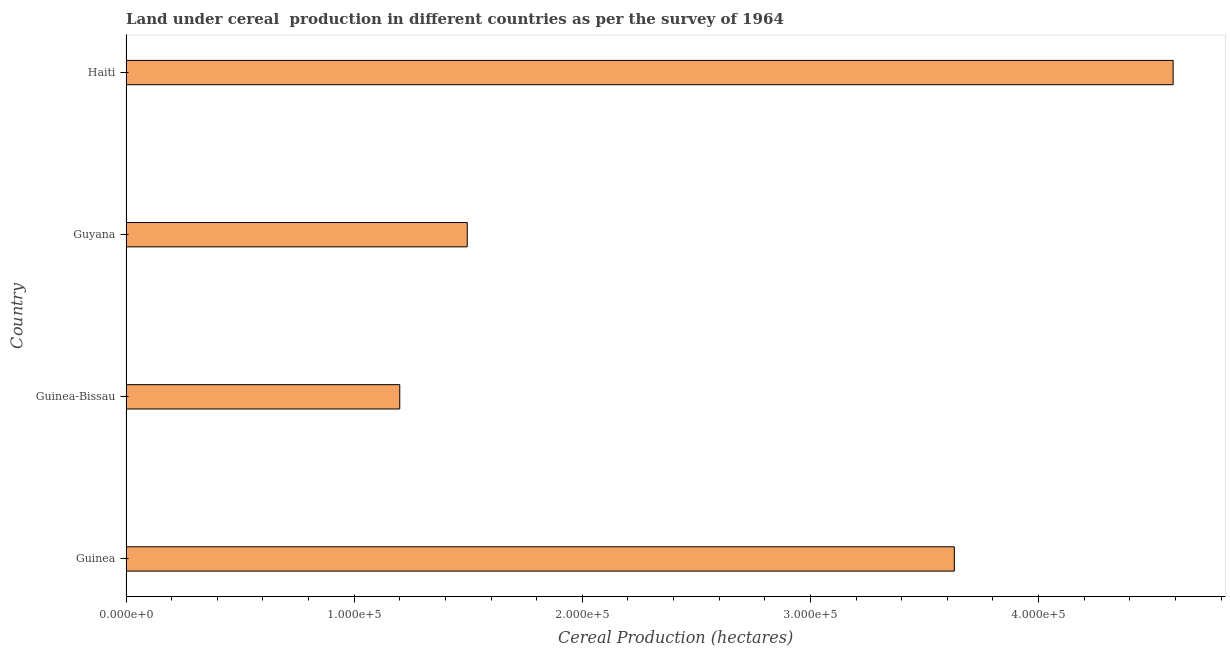What is the title of the graph?
Your response must be concise. Land under cereal  production in different countries as per the survey of 1964. What is the label or title of the X-axis?
Keep it short and to the point. Cereal Production (hectares). What is the land under cereal production in Guinea?
Your answer should be compact. 3.63e+05. Across all countries, what is the maximum land under cereal production?
Ensure brevity in your answer.  4.59e+05. Across all countries, what is the minimum land under cereal production?
Offer a very short reply. 1.20e+05. In which country was the land under cereal production maximum?
Provide a short and direct response. Haiti. In which country was the land under cereal production minimum?
Your answer should be very brief. Guinea-Bissau. What is the sum of the land under cereal production?
Make the answer very short. 1.09e+06. What is the difference between the land under cereal production in Guinea and Guyana?
Your response must be concise. 2.14e+05. What is the average land under cereal production per country?
Provide a short and direct response. 2.73e+05. What is the median land under cereal production?
Provide a succinct answer. 2.56e+05. What is the ratio of the land under cereal production in Guinea to that in Guyana?
Give a very brief answer. 2.43. Is the difference between the land under cereal production in Guinea and Haiti greater than the difference between any two countries?
Keep it short and to the point. No. What is the difference between the highest and the second highest land under cereal production?
Keep it short and to the point. 9.59e+04. Is the sum of the land under cereal production in Guinea and Guyana greater than the maximum land under cereal production across all countries?
Your answer should be compact. Yes. What is the difference between the highest and the lowest land under cereal production?
Your answer should be compact. 3.39e+05. How many countries are there in the graph?
Make the answer very short. 4. What is the Cereal Production (hectares) of Guinea?
Ensure brevity in your answer.  3.63e+05. What is the Cereal Production (hectares) of Guinea-Bissau?
Keep it short and to the point. 1.20e+05. What is the Cereal Production (hectares) in Guyana?
Provide a succinct answer. 1.50e+05. What is the Cereal Production (hectares) in Haiti?
Offer a very short reply. 4.59e+05. What is the difference between the Cereal Production (hectares) in Guinea and Guinea-Bissau?
Your response must be concise. 2.43e+05. What is the difference between the Cereal Production (hectares) in Guinea and Guyana?
Your answer should be very brief. 2.14e+05. What is the difference between the Cereal Production (hectares) in Guinea and Haiti?
Give a very brief answer. -9.59e+04. What is the difference between the Cereal Production (hectares) in Guinea-Bissau and Guyana?
Provide a short and direct response. -2.96e+04. What is the difference between the Cereal Production (hectares) in Guinea-Bissau and Haiti?
Keep it short and to the point. -3.39e+05. What is the difference between the Cereal Production (hectares) in Guyana and Haiti?
Offer a terse response. -3.09e+05. What is the ratio of the Cereal Production (hectares) in Guinea to that in Guinea-Bissau?
Your answer should be very brief. 3.03. What is the ratio of the Cereal Production (hectares) in Guinea to that in Guyana?
Your response must be concise. 2.43. What is the ratio of the Cereal Production (hectares) in Guinea to that in Haiti?
Provide a succinct answer. 0.79. What is the ratio of the Cereal Production (hectares) in Guinea-Bissau to that in Guyana?
Your answer should be compact. 0.8. What is the ratio of the Cereal Production (hectares) in Guinea-Bissau to that in Haiti?
Provide a short and direct response. 0.26. What is the ratio of the Cereal Production (hectares) in Guyana to that in Haiti?
Your response must be concise. 0.33. 